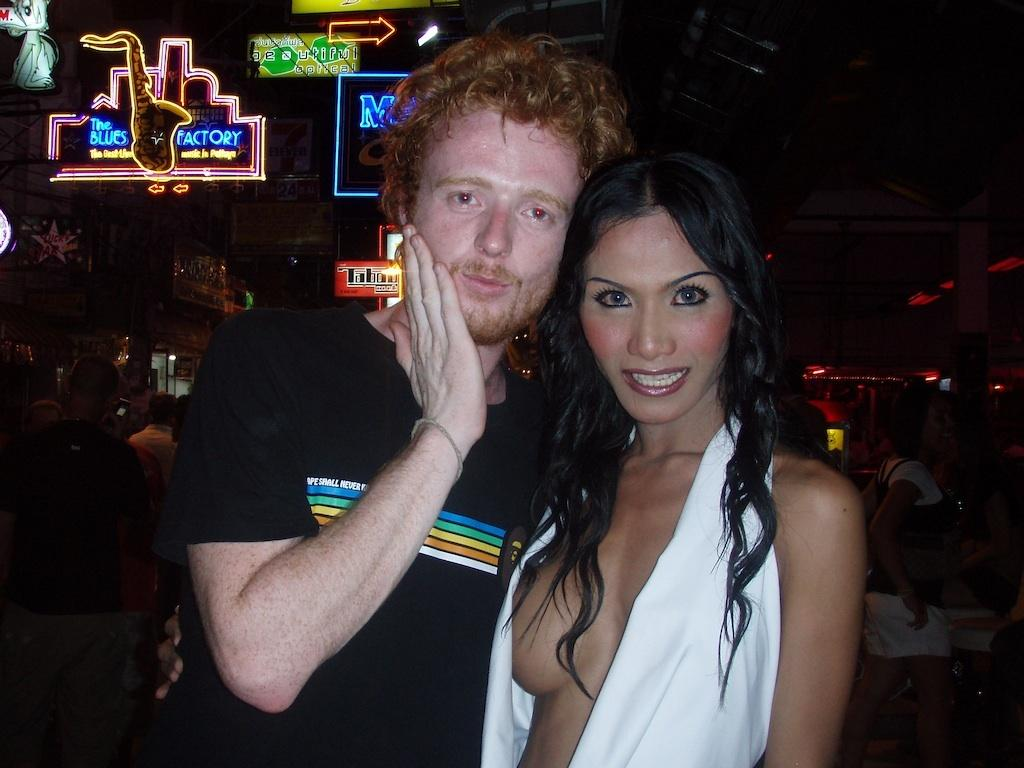Who are the people in the center of the image? There is a man and a lady standing in the center of the image. What can be seen in the background of the image? There are name boards and buildings in the background of the image. Can you see a playground in the image? There is no playground present in the image. How many stars are visible in the image? There are no stars visible in the image. 